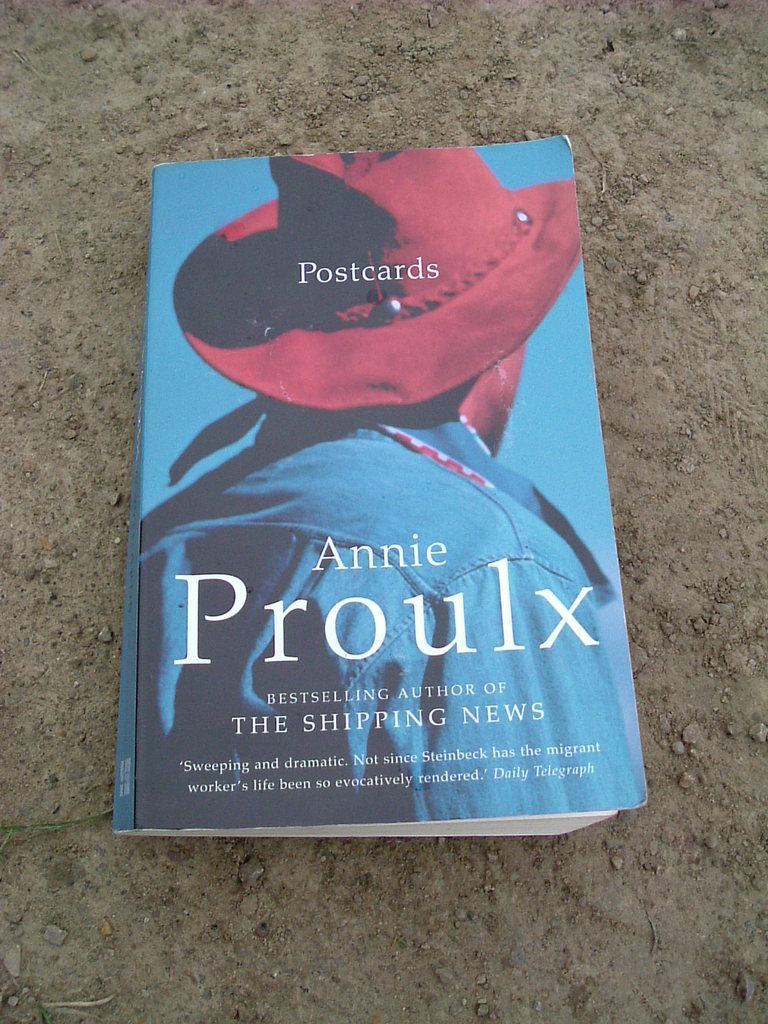In one or two sentences, can you explain what this image depicts? In the image there is a book on the land. 